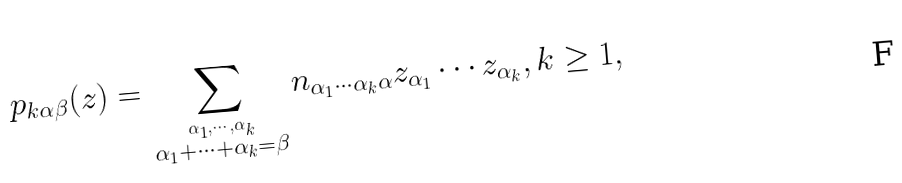Convert formula to latex. <formula><loc_0><loc_0><loc_500><loc_500>p _ { k \alpha \beta } ( z ) = \sum _ { \stackrel { \alpha _ { 1 } , \cdots , \alpha _ { k } } { \alpha _ { 1 } + \cdots + \alpha _ { k } = \beta } } n _ { \alpha _ { 1 } \cdots \alpha _ { k } \alpha } z _ { \alpha _ { 1 } } \cdots z _ { \alpha _ { k } } , k \geq 1 ,</formula> 